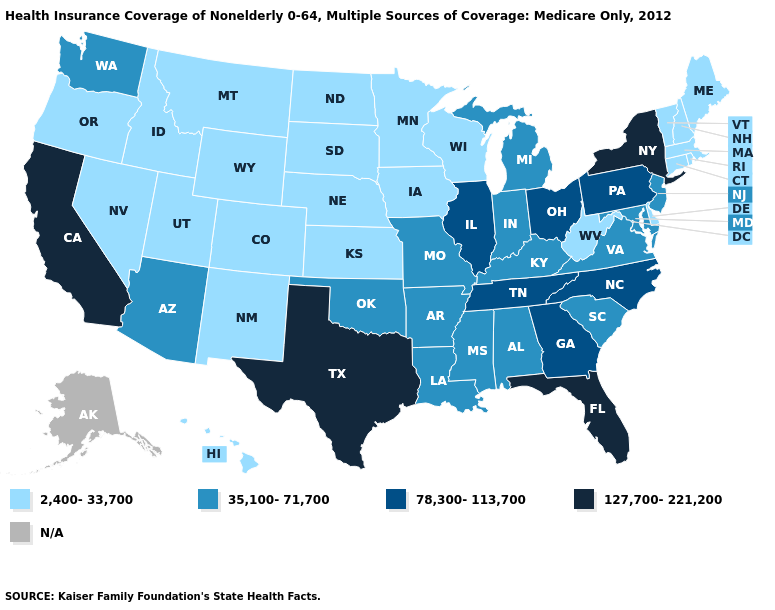Is the legend a continuous bar?
Write a very short answer. No. Does the first symbol in the legend represent the smallest category?
Be succinct. Yes. Among the states that border Tennessee , which have the highest value?
Keep it brief. Georgia, North Carolina. Which states hav the highest value in the West?
Answer briefly. California. What is the highest value in the USA?
Give a very brief answer. 127,700-221,200. What is the lowest value in the West?
Concise answer only. 2,400-33,700. Which states have the lowest value in the USA?
Quick response, please. Colorado, Connecticut, Delaware, Hawaii, Idaho, Iowa, Kansas, Maine, Massachusetts, Minnesota, Montana, Nebraska, Nevada, New Hampshire, New Mexico, North Dakota, Oregon, Rhode Island, South Dakota, Utah, Vermont, West Virginia, Wisconsin, Wyoming. Is the legend a continuous bar?
Give a very brief answer. No. What is the highest value in the USA?
Quick response, please. 127,700-221,200. Does Texas have the lowest value in the USA?
Short answer required. No. How many symbols are there in the legend?
Quick response, please. 5. Name the states that have a value in the range 35,100-71,700?
Short answer required. Alabama, Arizona, Arkansas, Indiana, Kentucky, Louisiana, Maryland, Michigan, Mississippi, Missouri, New Jersey, Oklahoma, South Carolina, Virginia, Washington. Which states hav the highest value in the South?
Give a very brief answer. Florida, Texas. What is the value of Nevada?
Write a very short answer. 2,400-33,700. 